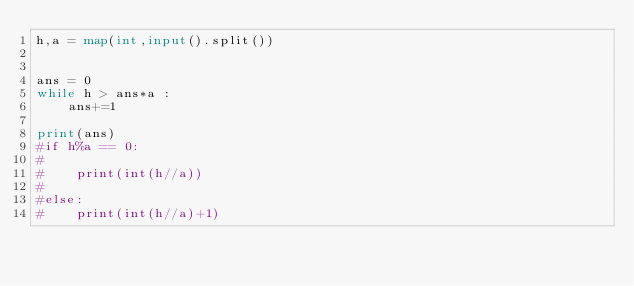<code> <loc_0><loc_0><loc_500><loc_500><_Python_>h,a = map(int,input().split())


ans = 0
while h > ans*a :
    ans+=1

print(ans)
#if h%a == 0:
#
#    print(int(h//a))
#
#else:
#    print(int(h//a)+1)</code> 